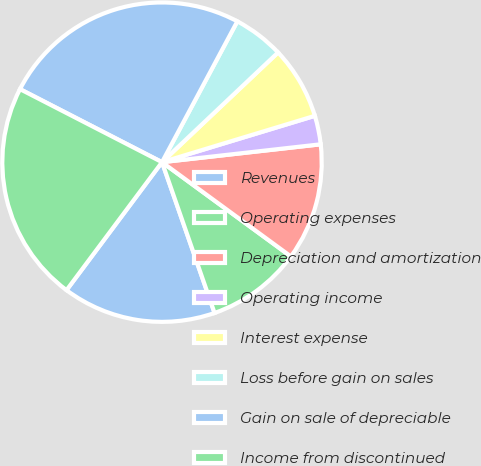Convert chart to OTSL. <chart><loc_0><loc_0><loc_500><loc_500><pie_chart><fcel>Revenues<fcel>Operating expenses<fcel>Depreciation and amortization<fcel>Operating income<fcel>Interest expense<fcel>Loss before gain on sales<fcel>Gain on sale of depreciable<fcel>Income from discontinued<nl><fcel>15.54%<fcel>9.61%<fcel>11.84%<fcel>2.9%<fcel>7.37%<fcel>5.13%<fcel>25.26%<fcel>22.36%<nl></chart> 